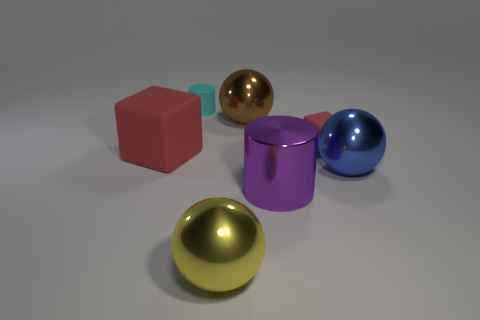Add 3 tiny green cubes. How many objects exist? 10 Subtract all spheres. How many objects are left? 4 Subtract all tiny matte objects. Subtract all tiny rubber cubes. How many objects are left? 4 Add 5 large blue metal objects. How many large blue metal objects are left? 6 Add 5 tiny things. How many tiny things exist? 7 Subtract 0 purple blocks. How many objects are left? 7 